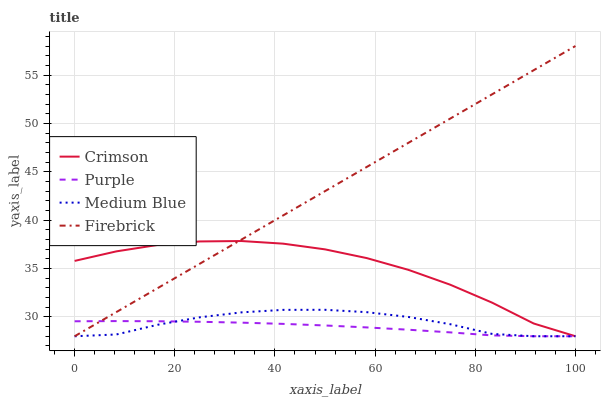Does Purple have the minimum area under the curve?
Answer yes or no. Yes. Does Firebrick have the maximum area under the curve?
Answer yes or no. Yes. Does Firebrick have the minimum area under the curve?
Answer yes or no. No. Does Purple have the maximum area under the curve?
Answer yes or no. No. Is Firebrick the smoothest?
Answer yes or no. Yes. Is Crimson the roughest?
Answer yes or no. Yes. Is Purple the smoothest?
Answer yes or no. No. Is Purple the roughest?
Answer yes or no. No. Does Crimson have the lowest value?
Answer yes or no. Yes. Does Firebrick have the highest value?
Answer yes or no. Yes. Does Purple have the highest value?
Answer yes or no. No. Does Crimson intersect Medium Blue?
Answer yes or no. Yes. Is Crimson less than Medium Blue?
Answer yes or no. No. Is Crimson greater than Medium Blue?
Answer yes or no. No. 